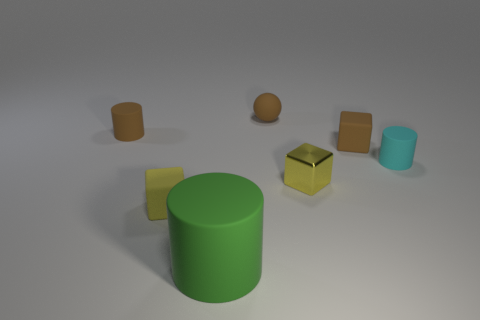Subtract all brown matte cubes. How many cubes are left? 2 Subtract 2 cylinders. How many cylinders are left? 1 Add 1 brown spheres. How many objects exist? 8 Subtract all cubes. How many objects are left? 4 Subtract all brown cubes. How many cubes are left? 2 Subtract all purple balls. How many purple blocks are left? 0 Subtract all tiny purple matte balls. Subtract all green things. How many objects are left? 6 Add 4 cyan objects. How many cyan objects are left? 5 Add 6 large metallic blocks. How many large metallic blocks exist? 6 Subtract 0 yellow cylinders. How many objects are left? 7 